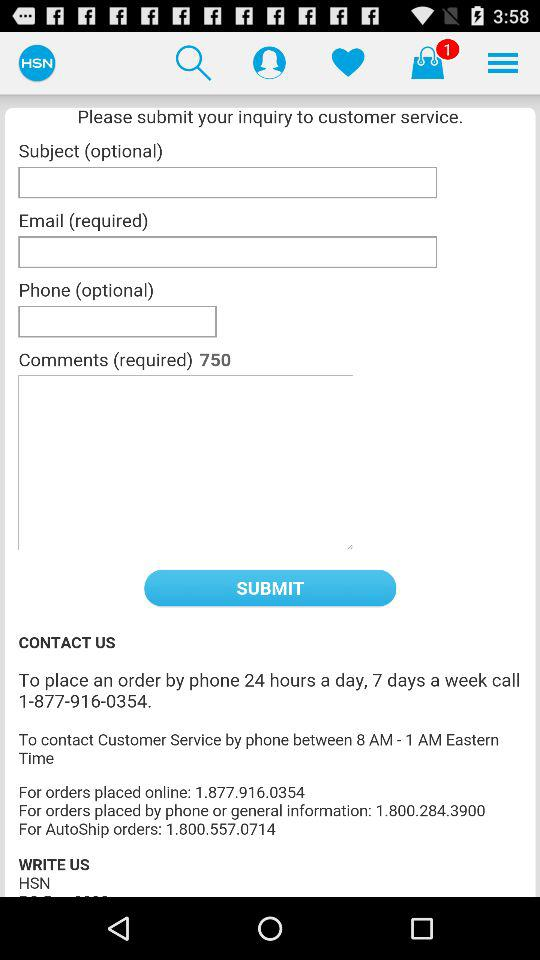How many required fields are there?
Answer the question using a single word or phrase. 3 